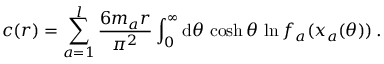Convert formula to latex. <formula><loc_0><loc_0><loc_500><loc_500>c ( r ) = \sum _ { a = 1 } ^ { l } \frac { 6 m _ { a } r } { \pi ^ { 2 } } \int _ { 0 } ^ { \infty } d \theta \, \cosh \theta \, \ln f _ { a } ( x _ { a } ( \theta ) ) \, .</formula> 